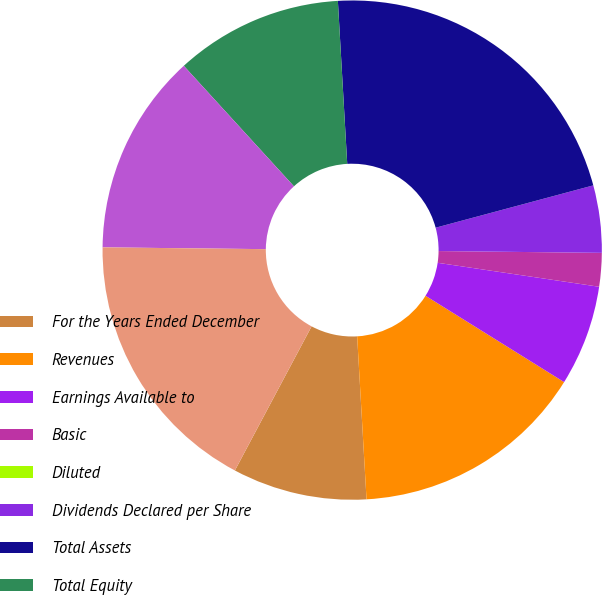Convert chart to OTSL. <chart><loc_0><loc_0><loc_500><loc_500><pie_chart><fcel>For the Years Ended December<fcel>Revenues<fcel>Earnings Available to<fcel>Basic<fcel>Diluted<fcel>Dividends Declared per Share<fcel>Total Assets<fcel>Total Equity<fcel>Long-Term Debt and Other<fcel>Total Capitalization<nl><fcel>8.7%<fcel>15.22%<fcel>6.52%<fcel>2.17%<fcel>0.0%<fcel>4.35%<fcel>21.74%<fcel>10.87%<fcel>13.04%<fcel>17.39%<nl></chart> 